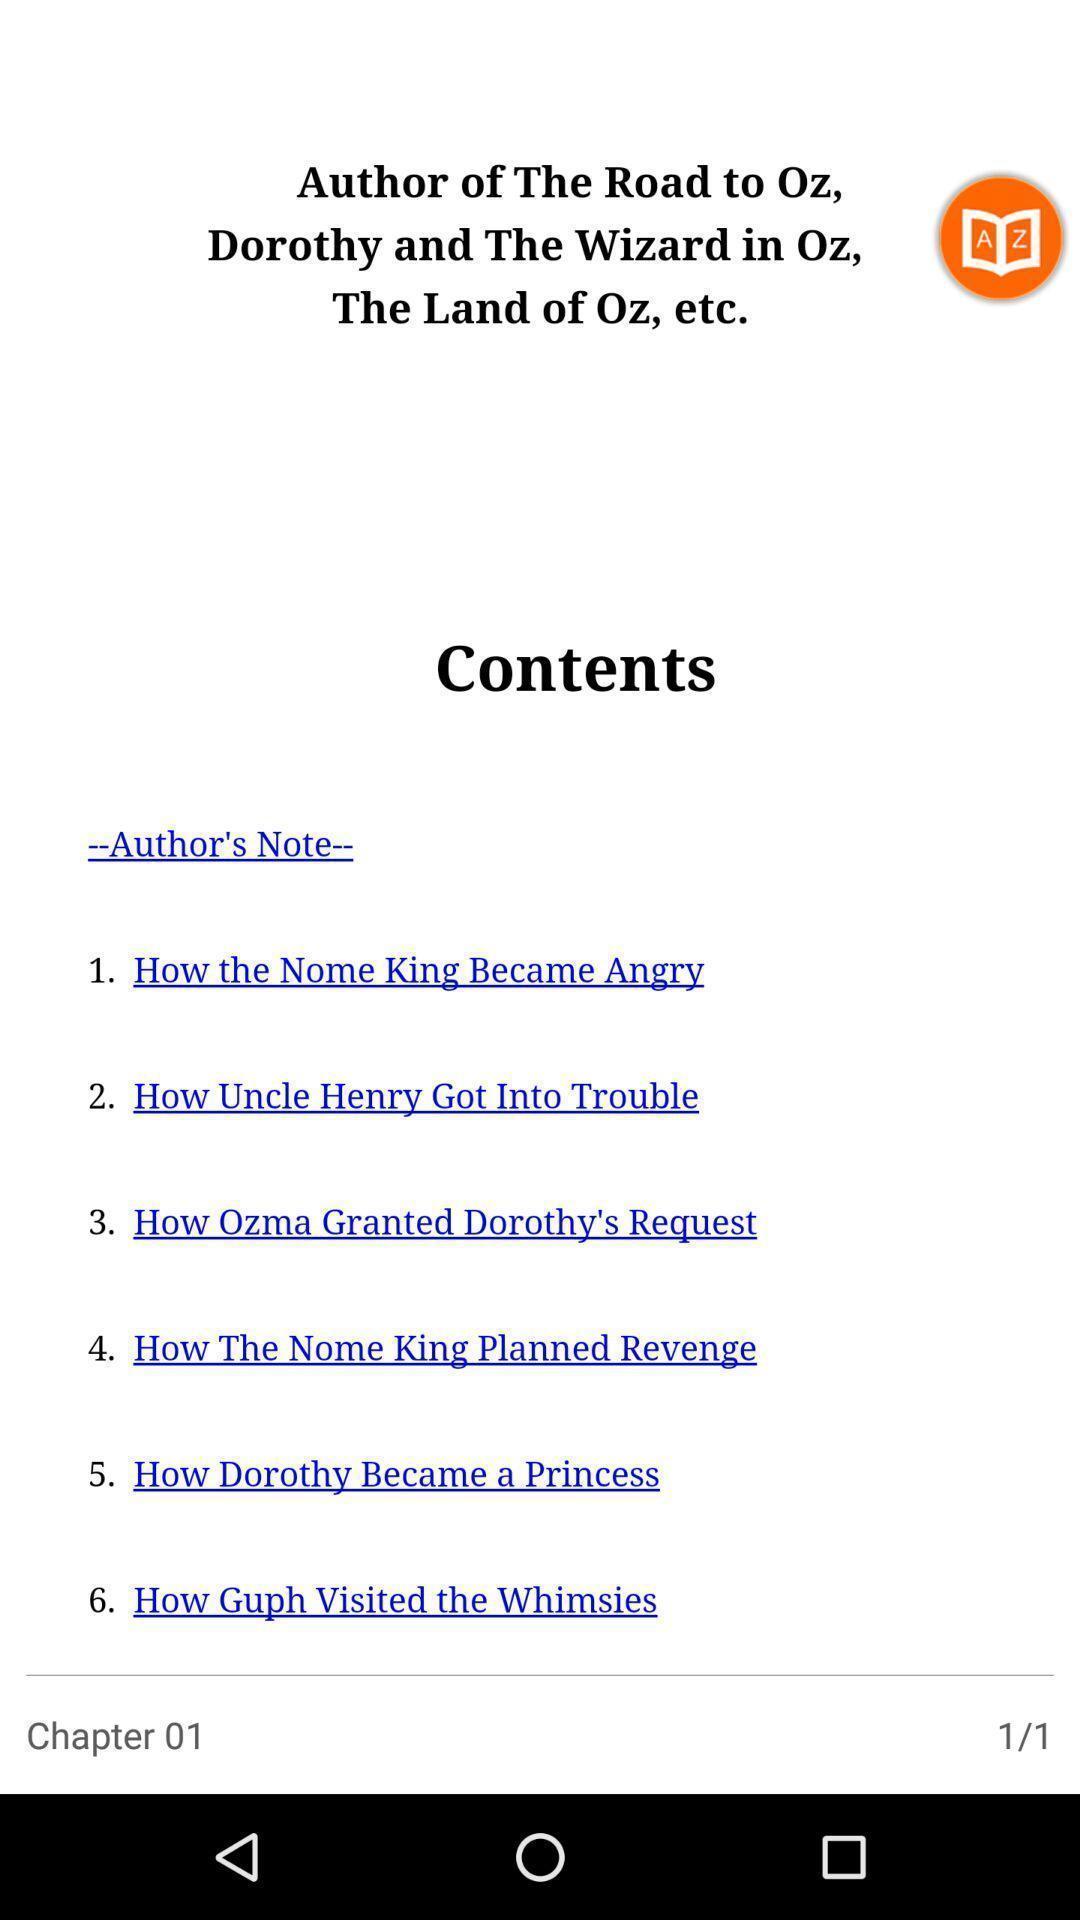Describe this image in words. Page showing different contents. 